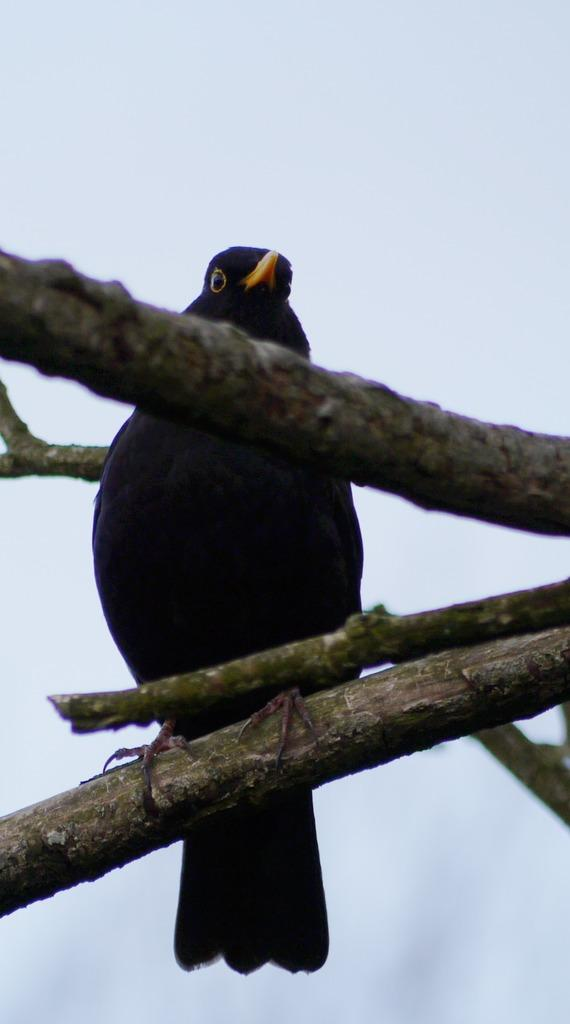What is located in the center of the image? There are words in the center of the image. What can be seen on the wood in the image? There is a bird on the wood in the image. What is the color of the bird? The bird is black in color. What is visible in the background of the image? Sky and clouds are present in the background of the image. How many giants are holding the crook in the image? There are no giants or crooks present in the image. 